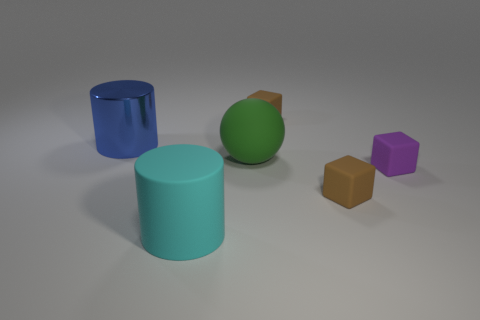Subtract all purple cubes. Subtract all purple cylinders. How many cubes are left? 2 Add 2 big green objects. How many objects exist? 8 Subtract all cylinders. How many objects are left? 4 Add 2 big blue objects. How many big blue objects are left? 3 Add 3 tiny blocks. How many tiny blocks exist? 6 Subtract 0 cyan cubes. How many objects are left? 6 Subtract all large red matte cylinders. Subtract all big blue metallic cylinders. How many objects are left? 5 